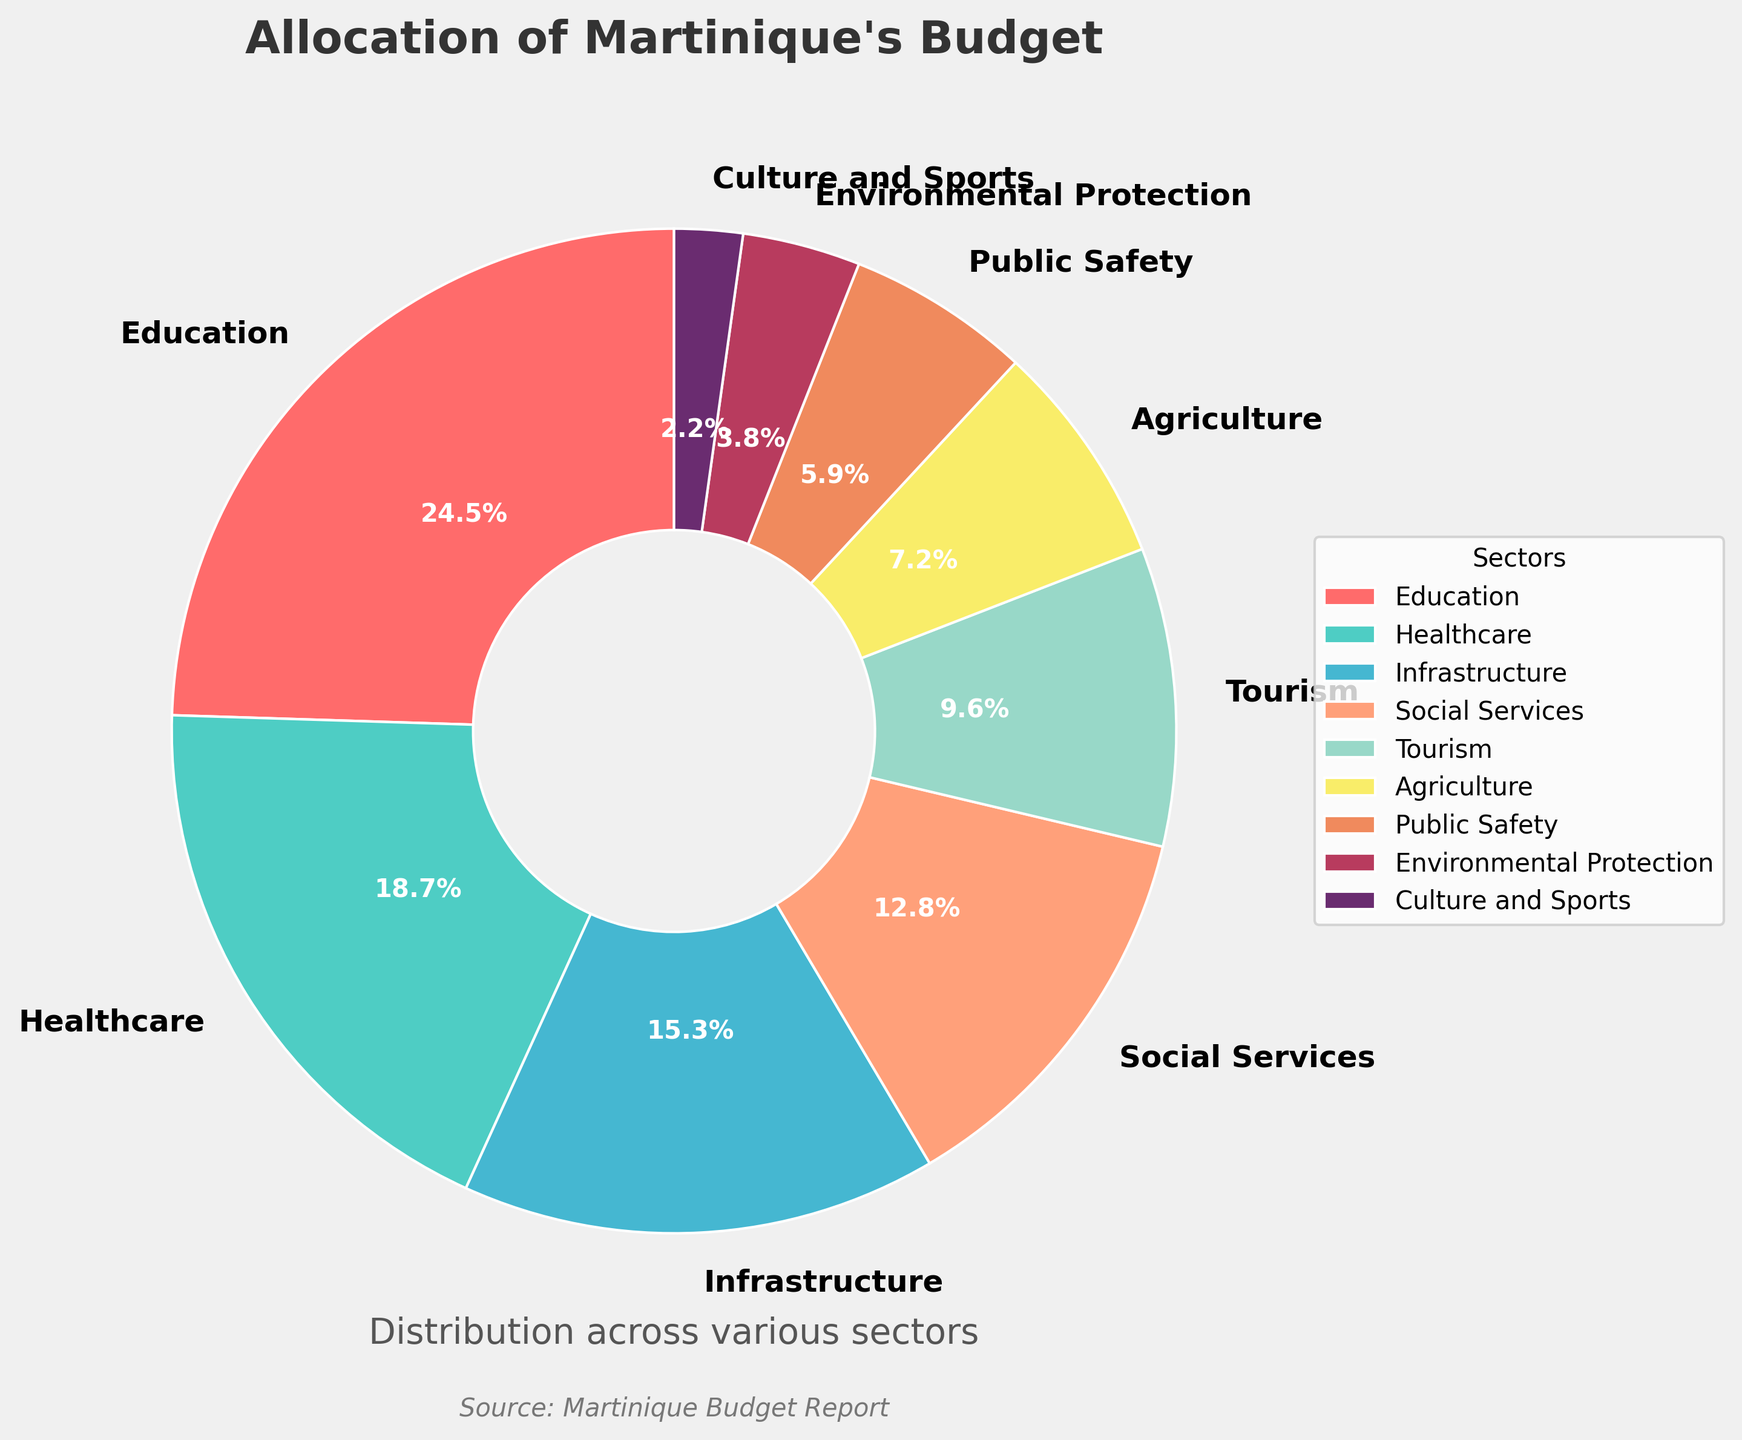What sector receives the largest portion of the budget? The pie chart shows different sectors' budget allocations. The sector with the largest portion is represented by the largest slice of the pie. This slice belongs to Education.
Answer: Education Which sector is allocated more budget, Healthcare or Infrastructure? To find out which sector has a larger allocation between Healthcare and Infrastructure, compare their percentages. Healthcare is 18.7%, while Infrastructure is 15.3%.
Answer: Healthcare What is the combined budget percentage for Education and Healthcare? To find the combined budget percentage, sum the percentages of Education (24.5%) and Healthcare (18.7%). 24.5% + 18.7% = 43.2%.
Answer: 43.2% How much more percentage is allocated to Social Services compared to Tourism? The percentage allocated to Social Services is 12.8%, and the percentage allocated to Tourism is 9.6%. To find out how much more, subtract the percentage of Tourism from Social Services: 12.8% - 9.6% = 3.2%.
Answer: 3.2% What is the total percentage allocation for sectors that have less than 10% budget? Sectors with less than 10% are Tourism (9.6%), Agriculture (7.2%), Public Safety (5.9%), Environmental Protection (3.8%), and Culture and Sports (2.2%). Sum these percentages: 9.6% + 7.2% + 5.9% + 3.8% + 2.2% = 28.7%.
Answer: 28.7% Which sector has the smallest allocation and what percentage is it? The smallest sector is represented by the smallest slice in the pie chart, which is Culture and Sports. The percentage for Culture and Sports is 2.2%.
Answer: Culture and Sports, 2.2% Are there any sectors that are allocated equally? To determine if any sectors are allocated equally, compare each sector's percentages. The pie chart shows all sectors have different percentages.
Answer: No If the budget allocation for Environmental Protection doubled, what percentage would it reach? The current budget allocation for Environmental Protection is 3.8%. If it doubled, it would be 3.8% * 2 = 7.6%.
Answer: 7.6% How does the color associated with Education in the pie chart compare to the color for Healthcare? Visually compare the pie chart colors for Education and Healthcare. Education is colored red, and Healthcare is colored turquoise.
Answer: Red vs Turquoise 